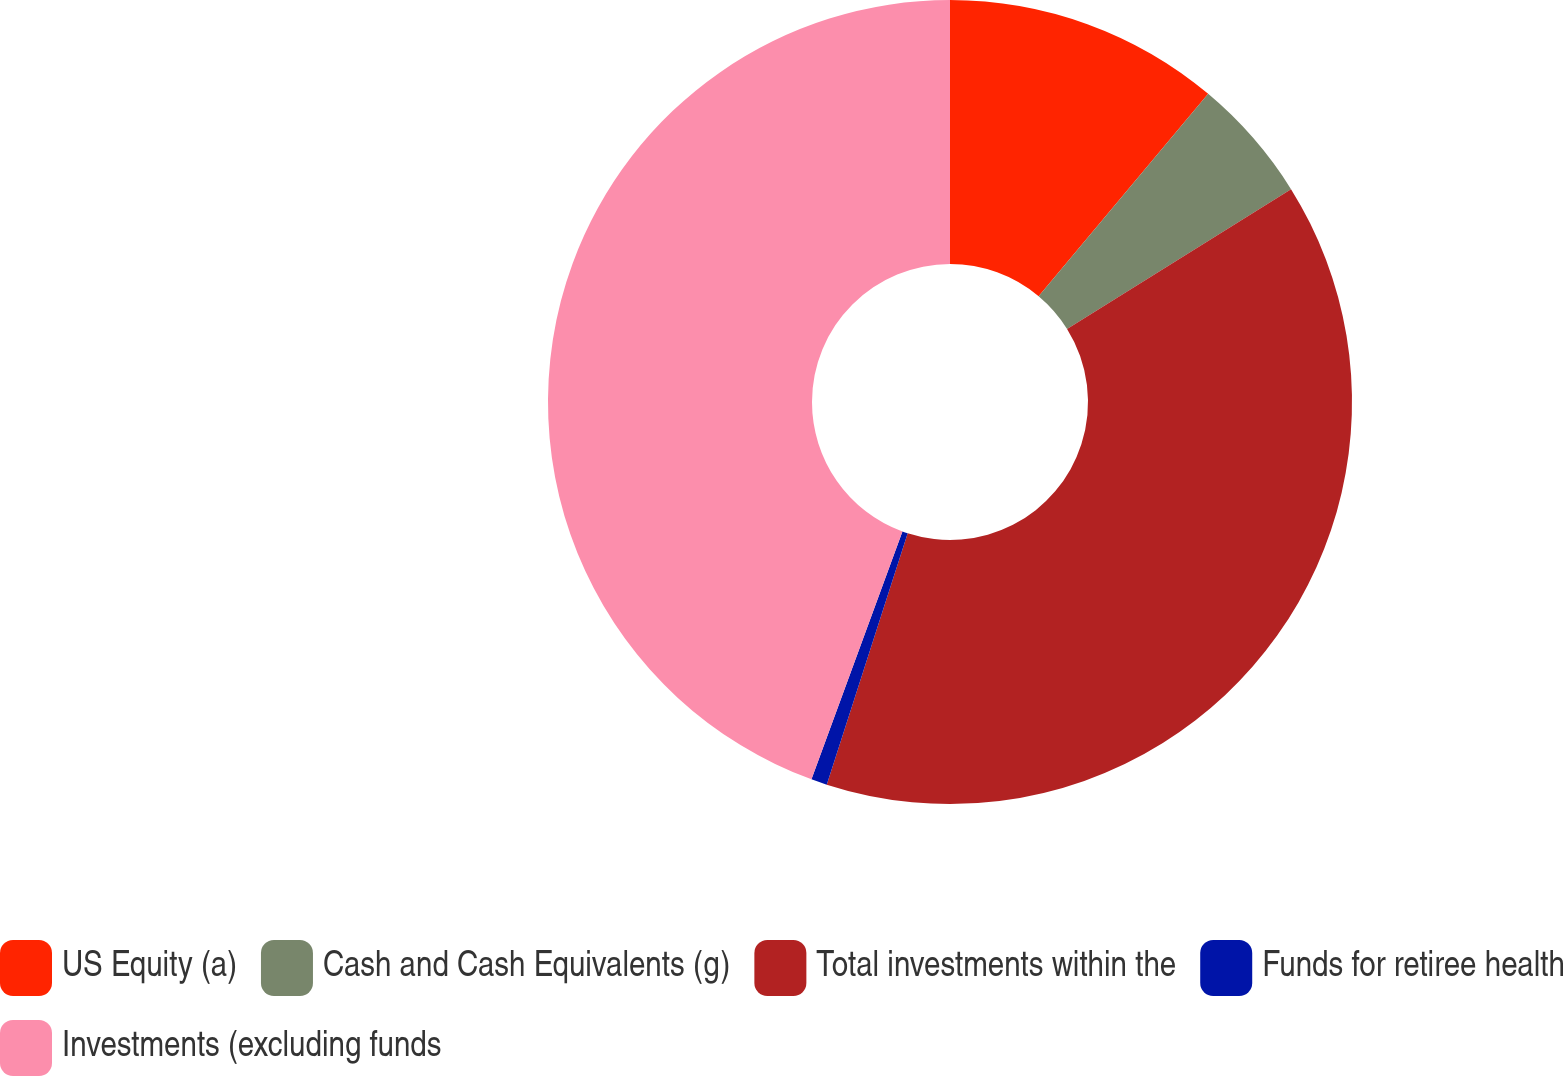Convert chart. <chart><loc_0><loc_0><loc_500><loc_500><pie_chart><fcel>US Equity (a)<fcel>Cash and Cash Equivalents (g)<fcel>Total investments within the<fcel>Funds for retiree health<fcel>Investments (excluding funds<nl><fcel>11.1%<fcel>5.02%<fcel>38.84%<fcel>0.64%<fcel>44.4%<nl></chart> 